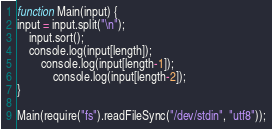<code> <loc_0><loc_0><loc_500><loc_500><_JavaScript_>
function Main(input) {
input = input.split("\n");
    input.sort();
	console.log(input[length]);
		console.log(input[length-1]);
			console.log(input[length-2]);
}
  
Main(require("fs").readFileSync("/dev/stdin", "utf8"));</code> 